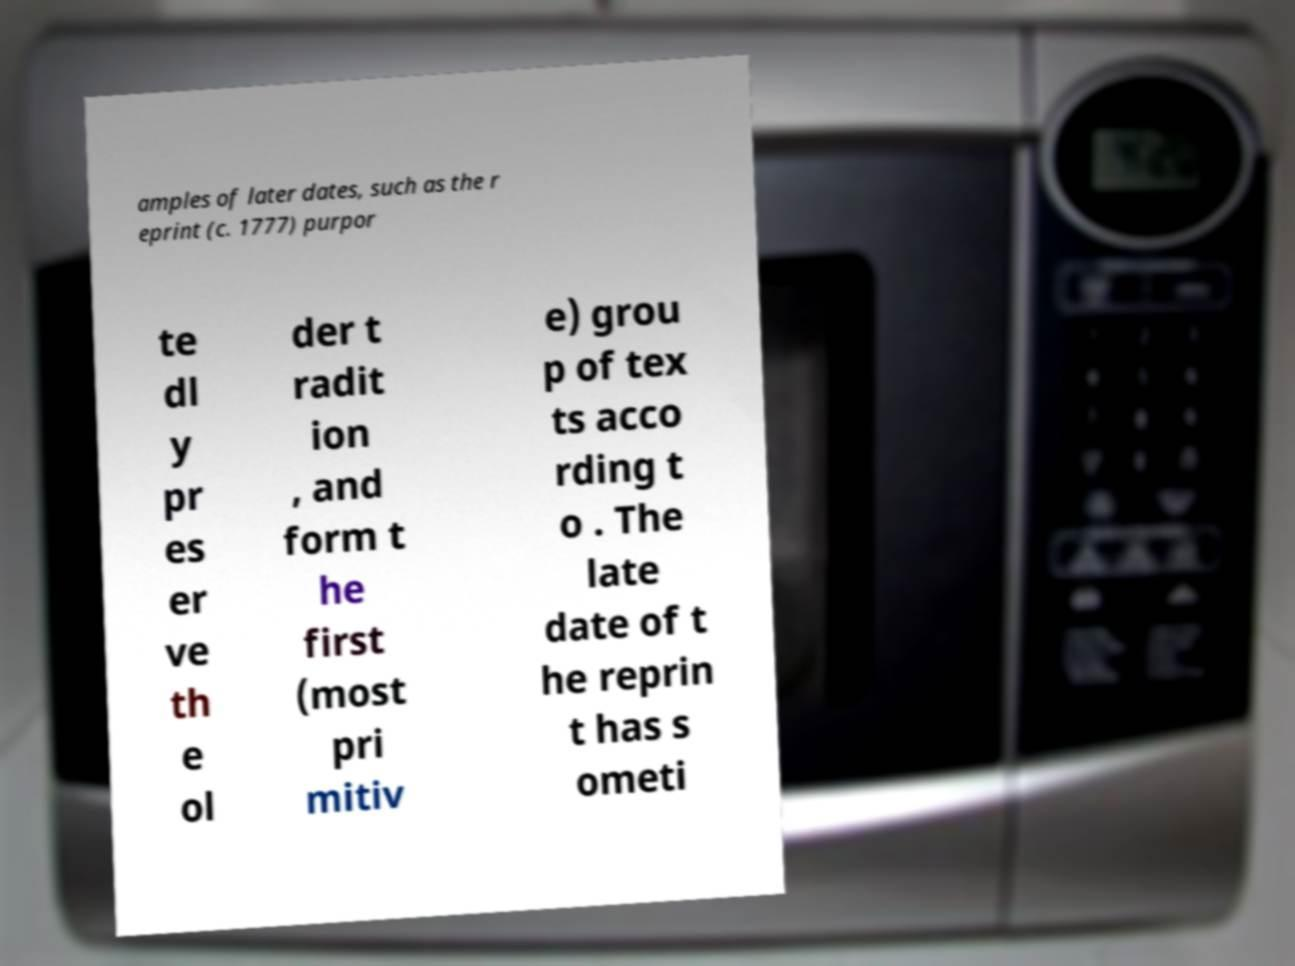Please identify and transcribe the text found in this image. amples of later dates, such as the r eprint (c. 1777) purpor te dl y pr es er ve th e ol der t radit ion , and form t he first (most pri mitiv e) grou p of tex ts acco rding t o . The late date of t he reprin t has s ometi 